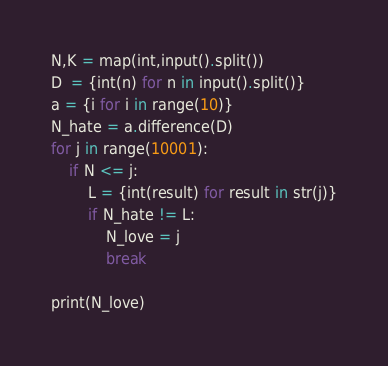Convert code to text. <code><loc_0><loc_0><loc_500><loc_500><_Python_>N,K = map(int,input().split())
D  = {int(n) for n in input().split()}
a = {i for i in range(10)}
N_hate = a.difference(D)
for j in range(10001):
    if N <= j:
        L = {int(result) for result in str(j)}
        if N_hate != L:
            N_love = j
            break

print(N_love)
</code> 